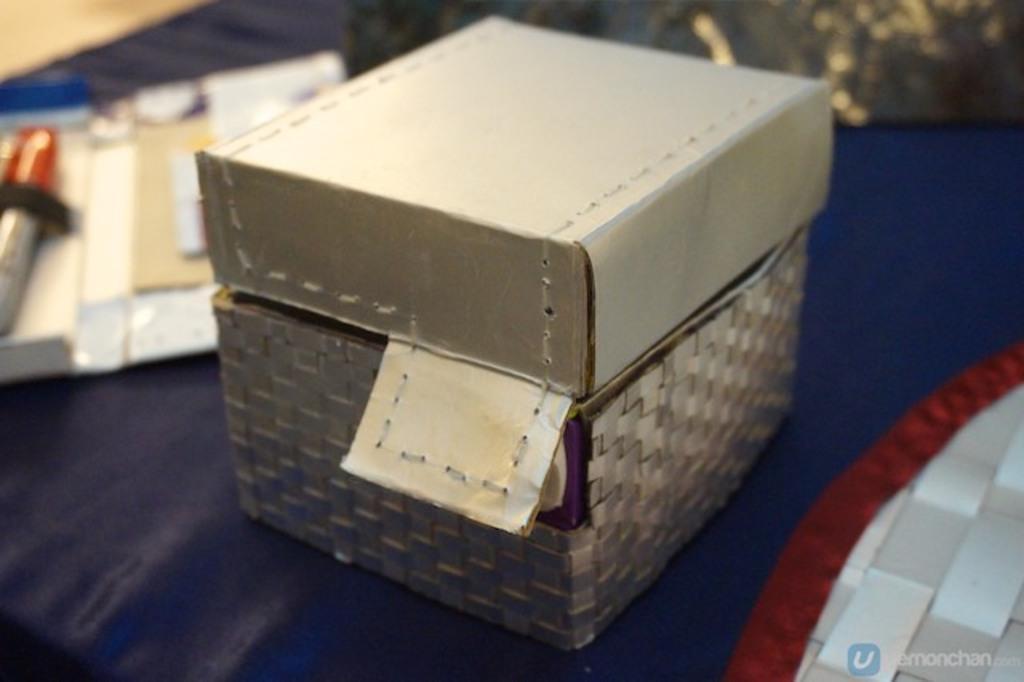Can you describe this image briefly? In this image there is a table on that table there is a box, in the background it is blurred. 